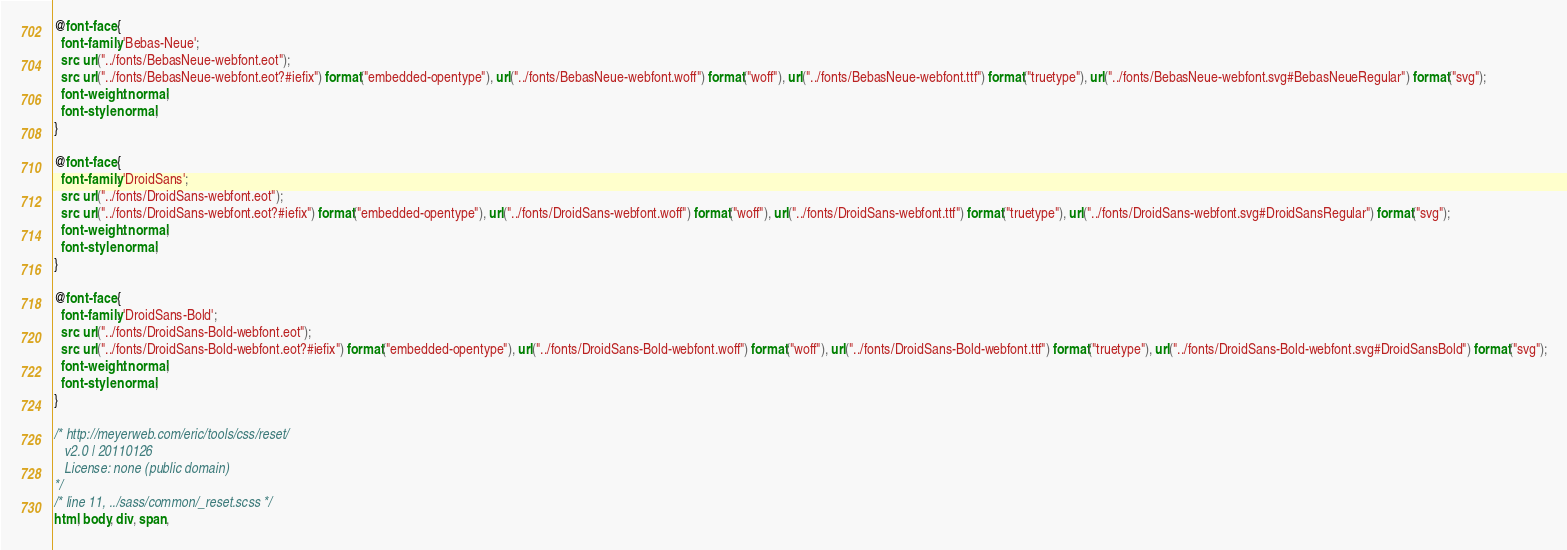Convert code to text. <code><loc_0><loc_0><loc_500><loc_500><_CSS_>@font-face {
  font-family: 'Bebas-Neue';
  src: url("../fonts/BebasNeue-webfont.eot");
  src: url("../fonts/BebasNeue-webfont.eot?#iefix") format("embedded-opentype"), url("../fonts/BebasNeue-webfont.woff") format("woff"), url("../fonts/BebasNeue-webfont.ttf") format("truetype"), url("../fonts/BebasNeue-webfont.svg#BebasNeueRegular") format("svg");
  font-weight: normal;
  font-style: normal;
}

@font-face {
  font-family: 'DroidSans';
  src: url("../fonts/DroidSans-webfont.eot");
  src: url("../fonts/DroidSans-webfont.eot?#iefix") format("embedded-opentype"), url("../fonts/DroidSans-webfont.woff") format("woff"), url("../fonts/DroidSans-webfont.ttf") format("truetype"), url("../fonts/DroidSans-webfont.svg#DroidSansRegular") format("svg");
  font-weight: normal;
  font-style: normal;
}

@font-face {
  font-family: 'DroidSans-Bold';
  src: url("../fonts/DroidSans-Bold-webfont.eot");
  src: url("../fonts/DroidSans-Bold-webfont.eot?#iefix") format("embedded-opentype"), url("../fonts/DroidSans-Bold-webfont.woff") format("woff"), url("../fonts/DroidSans-Bold-webfont.ttf") format("truetype"), url("../fonts/DroidSans-Bold-webfont.svg#DroidSansBold") format("svg");
  font-weight: normal;
  font-style: normal;
}

/* http://meyerweb.com/eric/tools/css/reset/
   v2.0 | 20110126
   License: none (public domain)
*/
/* line 11, ../sass/common/_reset.scss */
html, body, div, span,</code> 